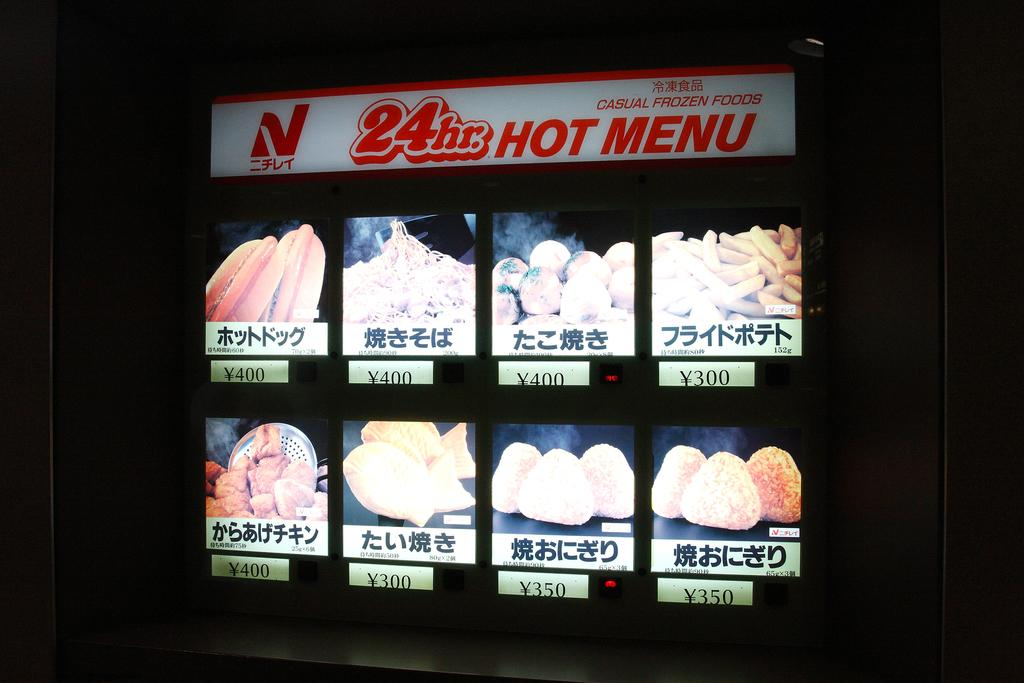What type of display board is visible in the image? There is a led display board in the image. How many men are standing next to the fang in the image? There is no mention of men or fangs in the image; it only features a led display board. 